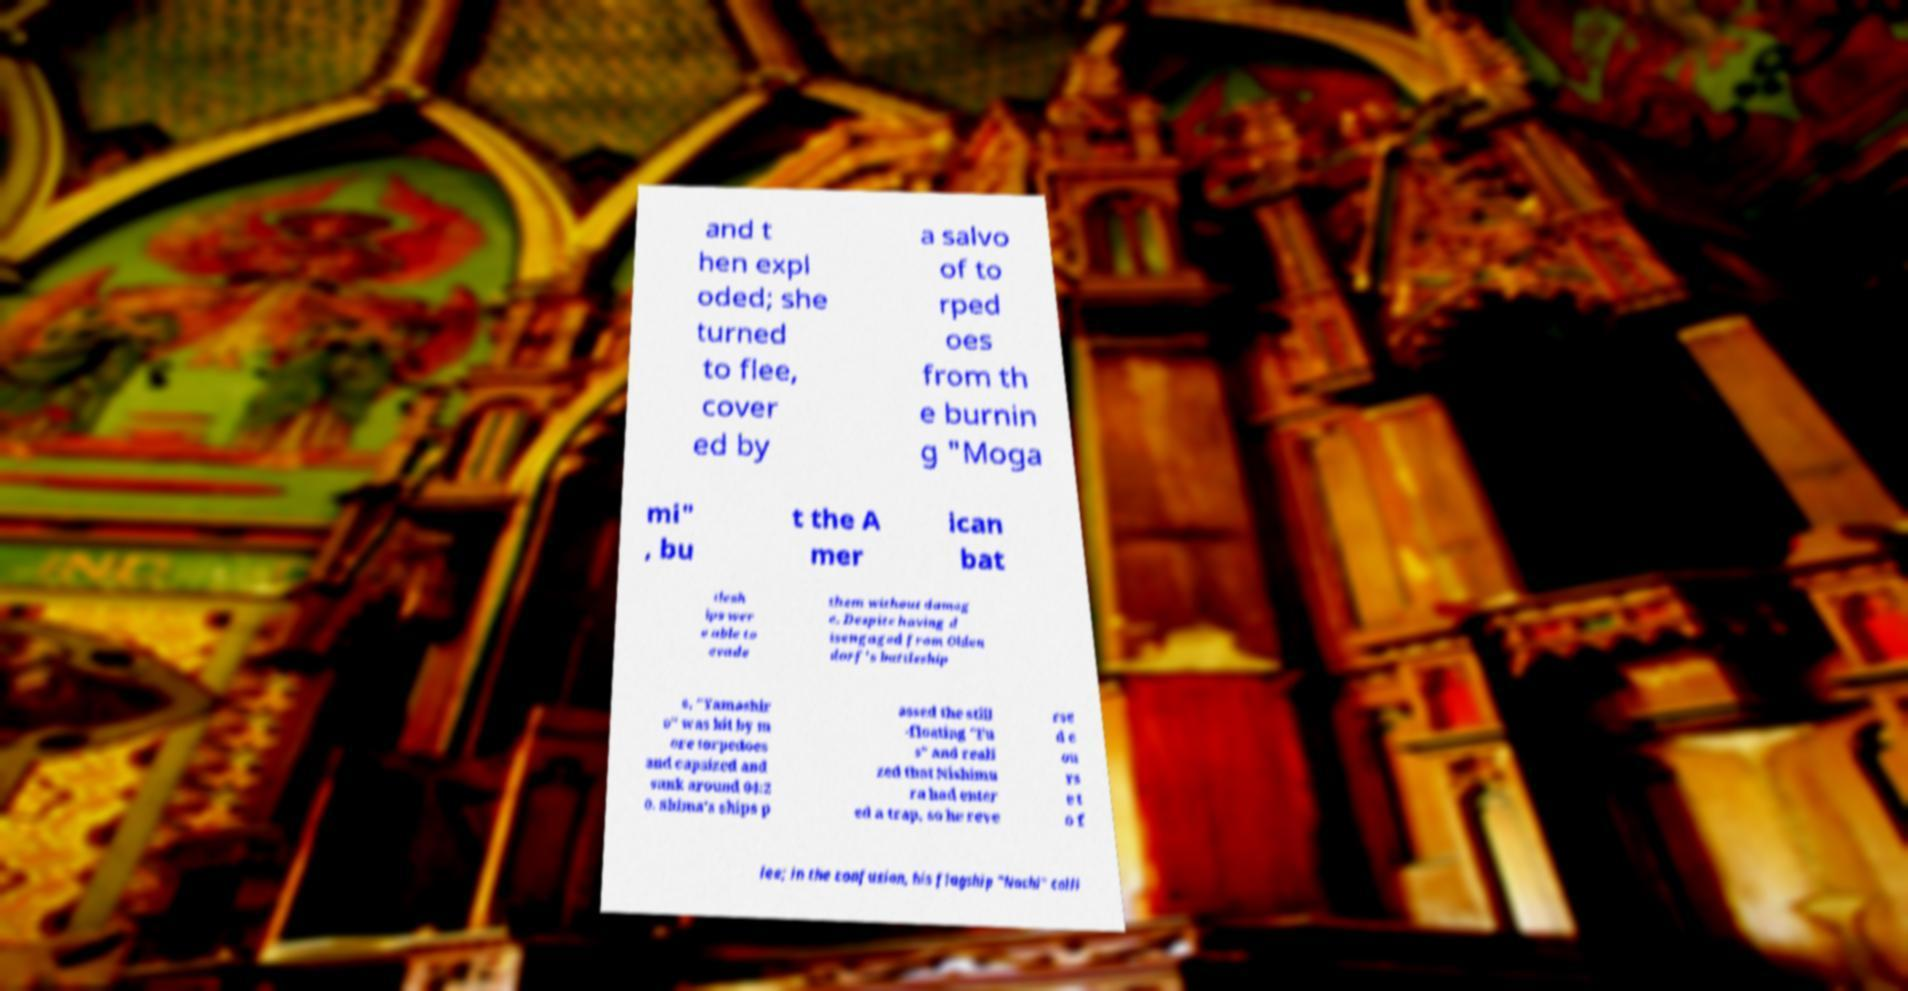For documentation purposes, I need the text within this image transcribed. Could you provide that? and t hen expl oded; she turned to flee, cover ed by a salvo of to rped oes from th e burnin g "Moga mi" , bu t the A mer ican bat tlesh ips wer e able to evade them without damag e. Despite having d isengaged from Olden dorf's battleship s, "Yamashir o" was hit by m ore torpedoes and capsized and sank around 04:2 0. Shima's ships p assed the still -floating "Fu s" and reali zed that Nishimu ra had enter ed a trap, so he reve rse d c ou rs e t o f lee; in the confusion, his flagship "Nachi" colli 